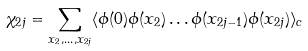Convert formula to latex. <formula><loc_0><loc_0><loc_500><loc_500>\chi _ { 2 j } = \sum _ { x _ { 2 } , \dots , x _ { 2 j } } \langle \phi ( 0 ) \phi ( x _ { 2 } ) \dots \phi ( x _ { 2 j - 1 } ) \phi ( x _ { 2 j } ) \rangle _ { c }</formula> 